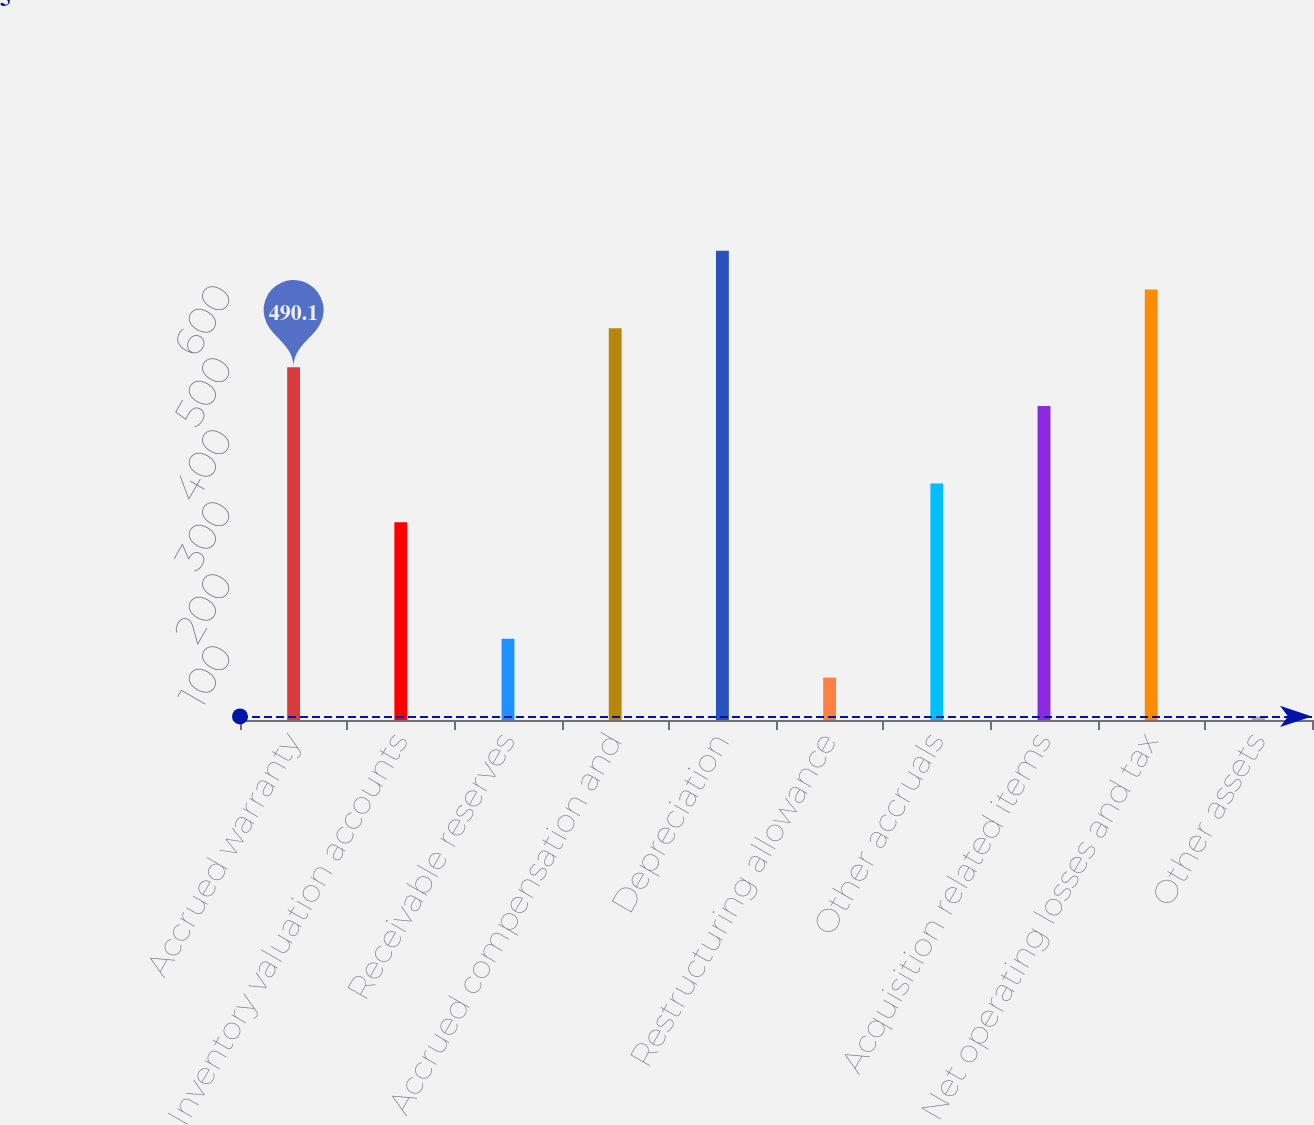Convert chart to OTSL. <chart><loc_0><loc_0><loc_500><loc_500><bar_chart><fcel>Accrued warranty<fcel>Inventory valuation accounts<fcel>Receivable reserves<fcel>Accrued compensation and<fcel>Depreciation<fcel>Restructuring allowance<fcel>Other accruals<fcel>Acquisition related items<fcel>Net operating losses and tax<fcel>Other assets<nl><fcel>490.1<fcel>274.5<fcel>112.8<fcel>544<fcel>651.8<fcel>58.9<fcel>328.4<fcel>436.2<fcel>597.9<fcel>5<nl></chart> 